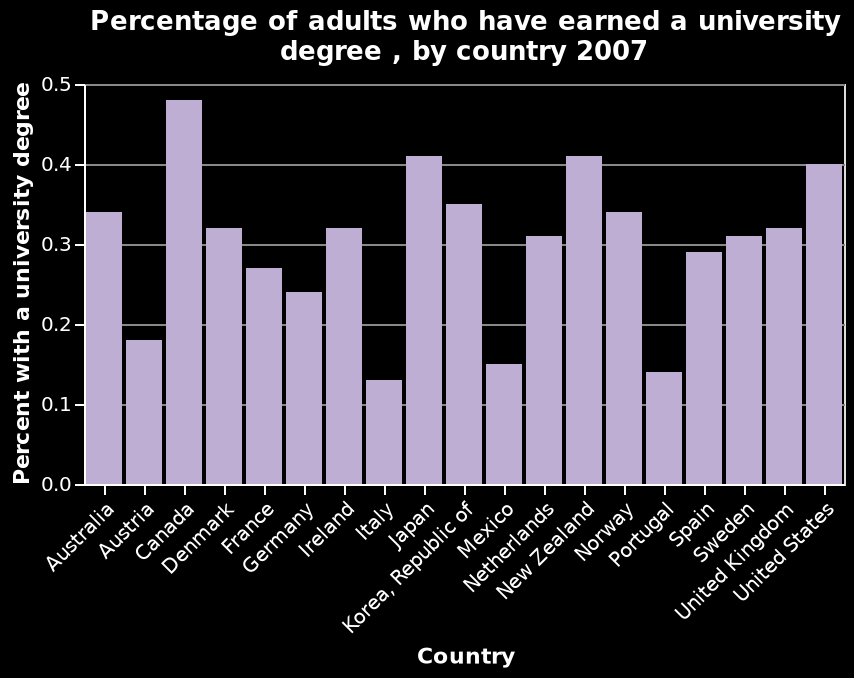<image>
What is shown on the y-axis of the bar chart? The y-axis represents the percentage of adults in each country who have earned a university degree. In which country do most people hold a university degree? Canada. Which country has the highest number of people with a university degree?  Canada. 